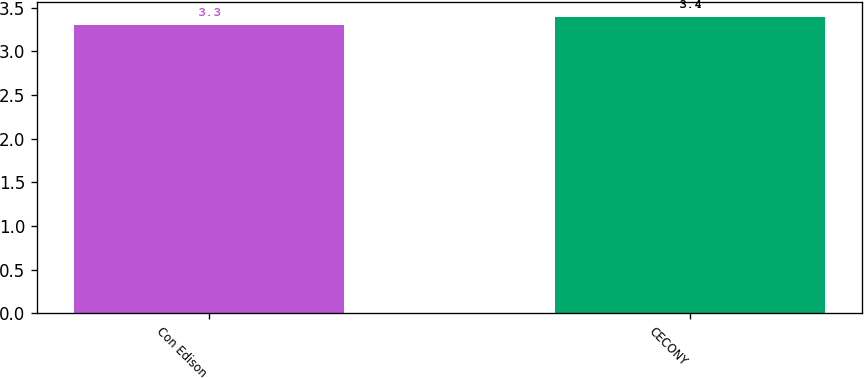Convert chart to OTSL. <chart><loc_0><loc_0><loc_500><loc_500><bar_chart><fcel>Con Edison<fcel>CECONY<nl><fcel>3.3<fcel>3.4<nl></chart> 